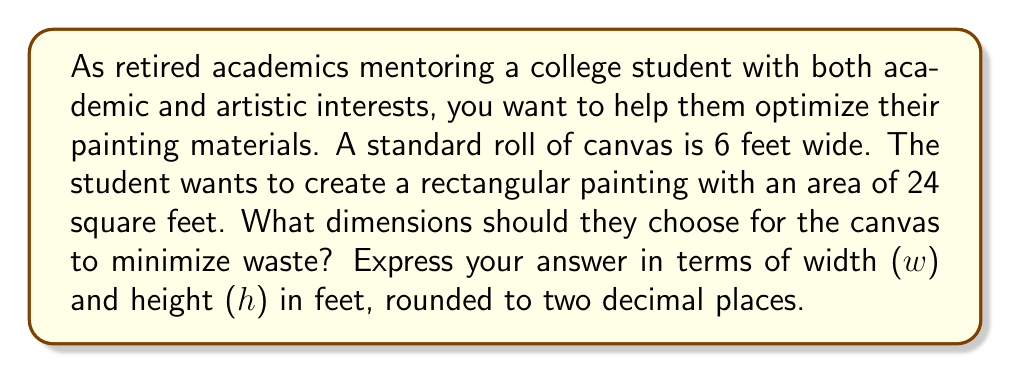What is the answer to this math problem? Let's approach this step-by-step:

1) We know that the area of the canvas should be 24 square feet. This gives us our first equation:

   $$ A = w \cdot h = 24 $$

2) We also know that the width of the canvas can't exceed 6 feet (the width of the roll). So:

   $$ 0 < w \leq 6 $$

3) To minimize waste, we want to use as much of the 6-foot width as possible. This suggests we should express the height in terms of the width:

   $$ h = \frac{24}{w} $$

4) Now, we need to consider the area of the unused portion of the canvas. For any given width $w$, the unused area will be:

   $$ \text{Unused Area} = 6h - 24 = 6 \cdot \frac{24}{w} - 24 = \frac{144}{w} - 24 $$

5) To minimize waste, we need to minimize this unused area. We can do this by finding the derivative of the unused area with respect to $w$ and setting it to zero:

   $$ \frac{d}{dw}(\frac{144}{w} - 24) = -\frac{144}{w^2} = 0 $$

6) Solving this equation:

   $$ -\frac{144}{w^2} = 0 $$
   $$ w^2 = \infty $$

   This suggests that the larger $w$ is, the less waste we have, up to the maximum of 6 feet.

7) Therefore, the optimal width is 6 feet. We can now calculate the height:

   $$ h = \frac{24}{6} = 4 $$

8) Let's verify that this indeed gives us 24 square feet:

   $$ A = 6 \cdot 4 = 24 \text{ sq ft} $$

Thus, the optimal dimensions are 6 feet wide by 4 feet high.
Answer: $w = 6.00$ feet, $h = 4.00$ feet 